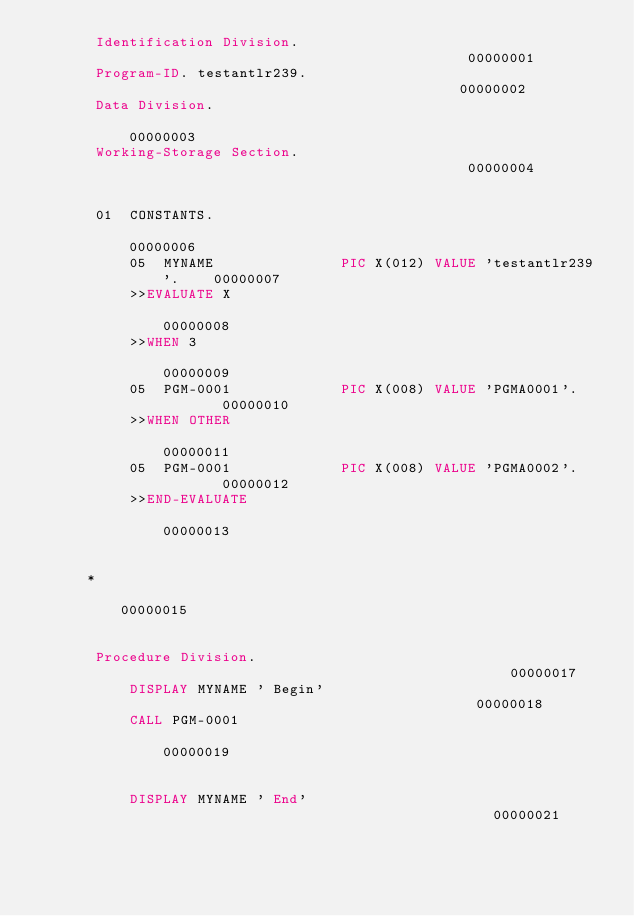<code> <loc_0><loc_0><loc_500><loc_500><_COBOL_>       Identification Division.                                         00000001
       Program-ID. testantlr239.                                        00000002
       Data Division.                                                   00000003
       Working-Storage Section.                                         00000004
                                                                        00000005
       01  CONSTANTS.                                                   00000006
           05  MYNAME               PIC X(012) VALUE 'testantlr239'.    00000007
           >>EVALUATE X                                                 00000008
           >>WHEN 3                                                     00000009
           05  PGM-0001             PIC X(008) VALUE 'PGMA0001'.        00000010
           >>WHEN OTHER                                                 00000011
           05  PGM-0001             PIC X(008) VALUE 'PGMA0002'.        00000012
           >>END-EVALUATE                                               00000013
                                                                        00000014
      *                                                                 00000015
                                                                        00000016
       Procedure Division.                                              00000017
           DISPLAY MYNAME ' Begin'                                      00000018
           CALL PGM-0001                                                00000019
                                                                        00000020
           DISPLAY MYNAME ' End'                                        00000021
                                                                        00000022</code> 